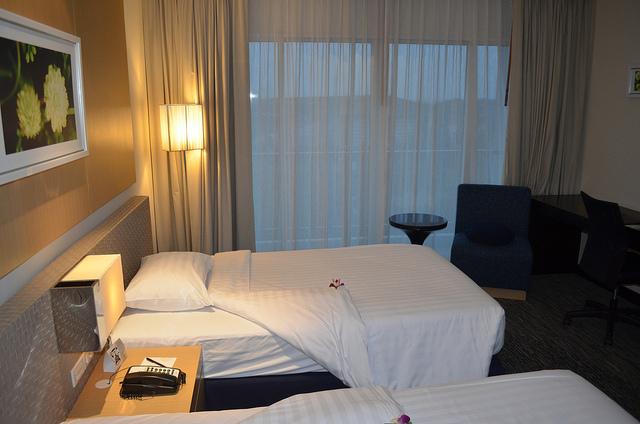What color are the curtains?
Concise answer only. White. Is the room ready?
Give a very brief answer. Yes. Are the curtains open or shut?
Be succinct. Shut. What color are the bedspreads?
Keep it brief. White. How many lamps are there?
Quick response, please. 1. Which side of the bed is the lamp?
Be succinct. Left. About what time was this photo taken?
Be succinct. Evening. Are the windows covered?
Quick response, please. Yes. How many windows are open?
Quick response, please. 0. How many pillows are there?
Quick response, please. 1. Why would a rainbow picture stand out in this room?
Be succinct. Room is white. Is this a hotel room or a bedroom?
Concise answer only. Hotel room. Is it night or day outside the window?
Concise answer only. Night. 